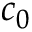Convert formula to latex. <formula><loc_0><loc_0><loc_500><loc_500>c _ { 0 }</formula> 